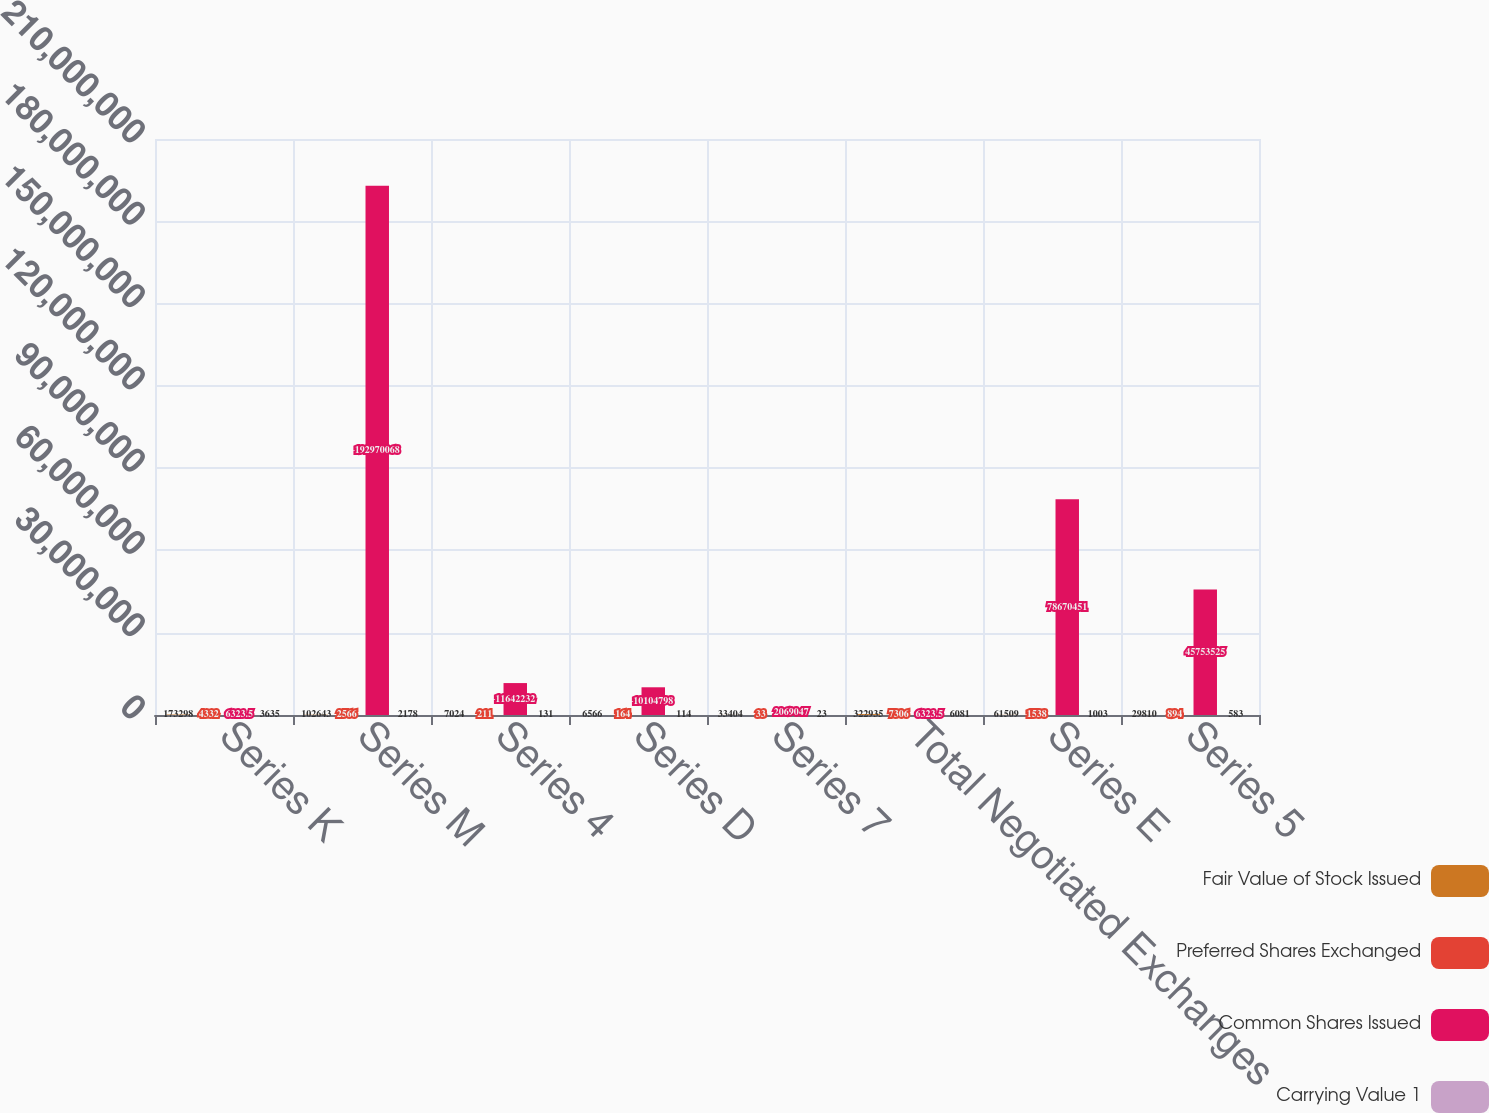<chart> <loc_0><loc_0><loc_500><loc_500><stacked_bar_chart><ecel><fcel>Series K<fcel>Series M<fcel>Series 4<fcel>Series D<fcel>Series 7<fcel>Total Negotiated Exchanges<fcel>Series E<fcel>Series 5<nl><fcel>Fair Value of Stock Issued<fcel>173298<fcel>102643<fcel>7024<fcel>6566<fcel>33404<fcel>322935<fcel>61509<fcel>29810<nl><fcel>Preferred Shares Exchanged<fcel>4332<fcel>2566<fcel>211<fcel>164<fcel>33<fcel>7306<fcel>1538<fcel>894<nl><fcel>Common Shares Issued<fcel>6323.5<fcel>1.9297e+08<fcel>1.16422e+07<fcel>1.01048e+07<fcel>2.06905e+06<fcel>6323.5<fcel>7.86705e+07<fcel>4.57535e+07<nl><fcel>Carrying Value 1<fcel>3635<fcel>2178<fcel>131<fcel>114<fcel>23<fcel>6081<fcel>1003<fcel>583<nl></chart> 